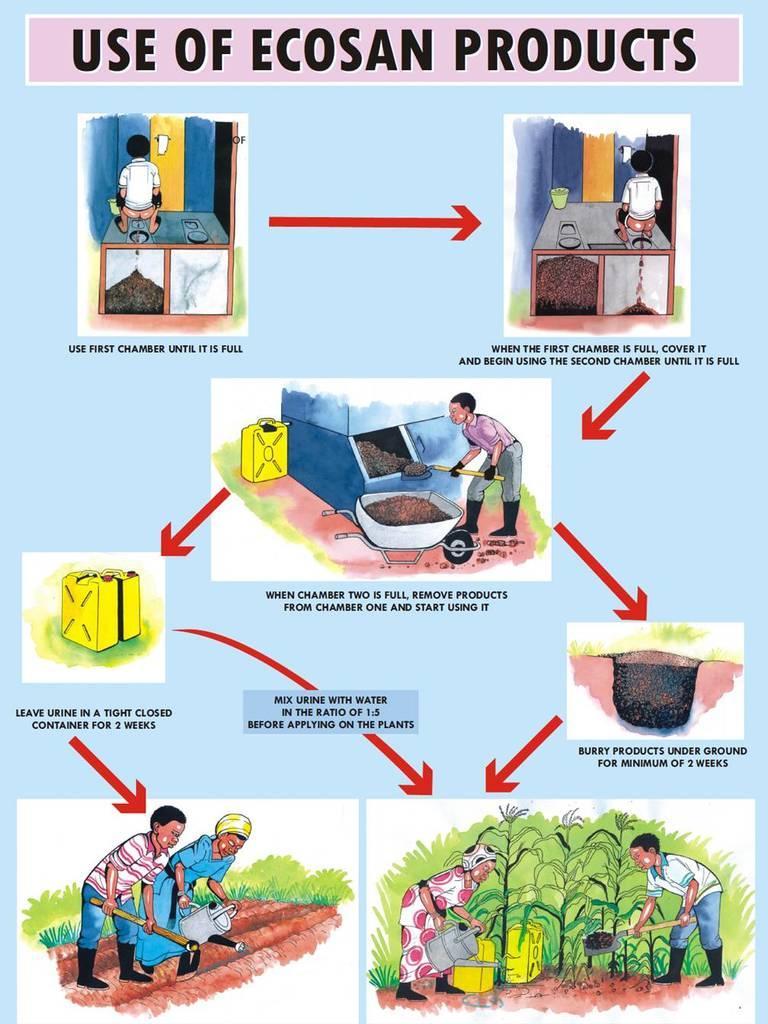Can you describe this image briefly? In this picture we can see the poster. In that we can see a boy who is standing near to the door. In the center we can see a man who is working. In the bottom there are two persons were working on the farm land. 